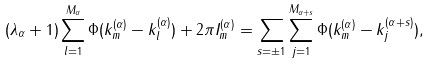<formula> <loc_0><loc_0><loc_500><loc_500>( \lambda _ { \alpha } + 1 ) \sum _ { l = 1 } ^ { M _ { \alpha } } \Phi ( k _ { m } ^ { ( \alpha ) } - k _ { l } ^ { ( \alpha ) } ) + 2 \pi I _ { m } ^ { ( \alpha ) } = \sum _ { s = \pm 1 } \sum _ { j = 1 } ^ { M _ { \alpha + s } } \Phi ( k _ { m } ^ { ( \alpha ) } - k _ { j } ^ { ( \alpha + s ) } ) ,</formula> 